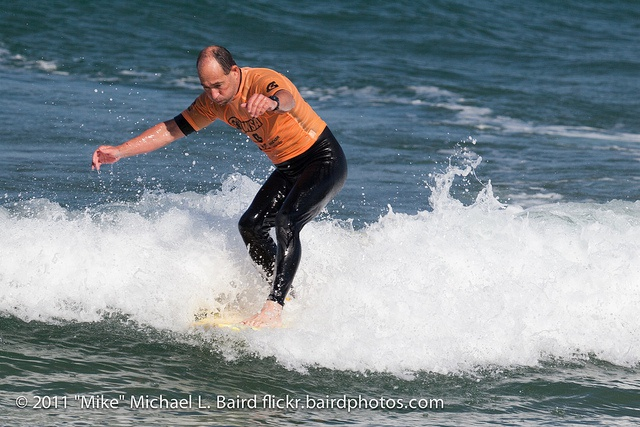Describe the objects in this image and their specific colors. I can see people in black, salmon, maroon, and gray tones and surfboard in black, tan, lightgray, and darkgray tones in this image. 